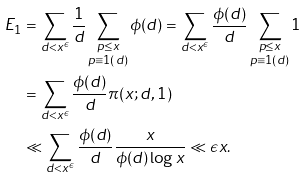Convert formula to latex. <formula><loc_0><loc_0><loc_500><loc_500>E _ { 1 } & = \sum _ { d < x ^ { \epsilon } } \frac { 1 } { d } \sum _ { \substack { { p \leq x } \\ { p \equiv 1 ( d ) } } } \phi ( d ) = \sum _ { d < x ^ { \epsilon } } \frac { \phi ( d ) } d \sum _ { \substack { { p \leq x } \\ { p \equiv 1 ( d ) } } } 1 \\ & = \sum _ { d < x ^ { \epsilon } } \frac { \phi ( d ) } d \pi ( x ; d , 1 ) \\ & \ll \sum _ { d < x ^ { \epsilon } } \frac { \phi ( d ) } d \frac { x } { \phi ( d ) \log x } \ll \epsilon x .</formula> 